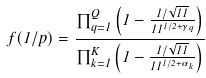Convert formula to latex. <formula><loc_0><loc_0><loc_500><loc_500>f ( 1 / p ) = \frac { \prod _ { q = 1 } ^ { Q } \left ( 1 - \frac { 1 / \sqrt { 1 1 } } { 1 1 ^ { 1 / 2 + \gamma _ { q } } } \right ) } { \prod _ { k = 1 } ^ { K } \left ( 1 - \frac { 1 / \sqrt { 1 1 } } { 1 1 ^ { 1 / 2 + \alpha _ { k } } } \right ) }</formula> 